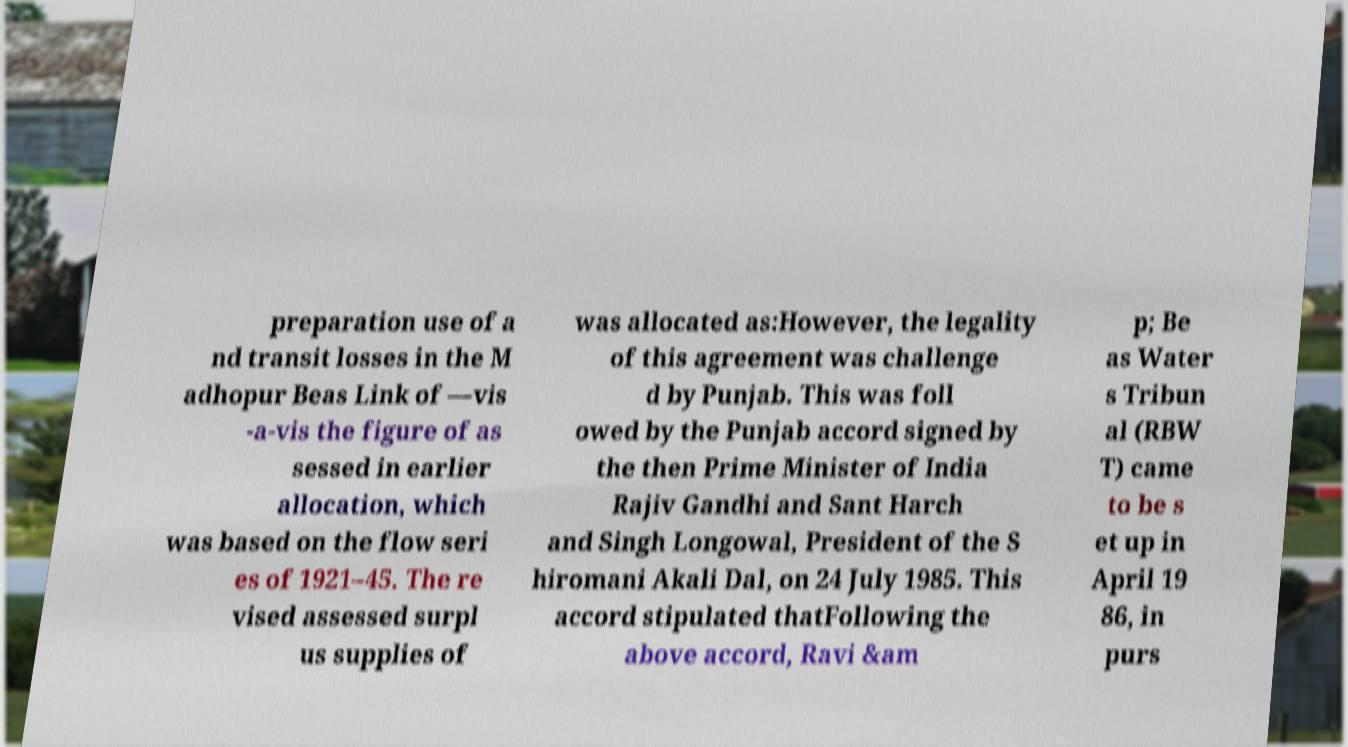Could you extract and type out the text from this image? preparation use of a nd transit losses in the M adhopur Beas Link of —vis -a-vis the figure of as sessed in earlier allocation, which was based on the flow seri es of 1921–45. The re vised assessed surpl us supplies of was allocated as:However, the legality of this agreement was challenge d by Punjab. This was foll owed by the Punjab accord signed by the then Prime Minister of India Rajiv Gandhi and Sant Harch and Singh Longowal, President of the S hiromani Akali Dal, on 24 July 1985. This accord stipulated thatFollowing the above accord, Ravi &am p; Be as Water s Tribun al (RBW T) came to be s et up in April 19 86, in purs 